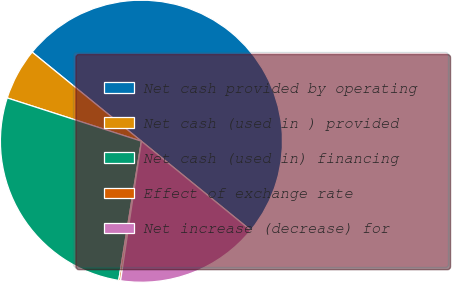<chart> <loc_0><loc_0><loc_500><loc_500><pie_chart><fcel>Net cash provided by operating<fcel>Net cash (used in ) provided<fcel>Net cash (used in) financing<fcel>Effect of exchange rate<fcel>Net increase (decrease) for<nl><fcel>50.0%<fcel>5.92%<fcel>27.39%<fcel>0.21%<fcel>16.48%<nl></chart> 